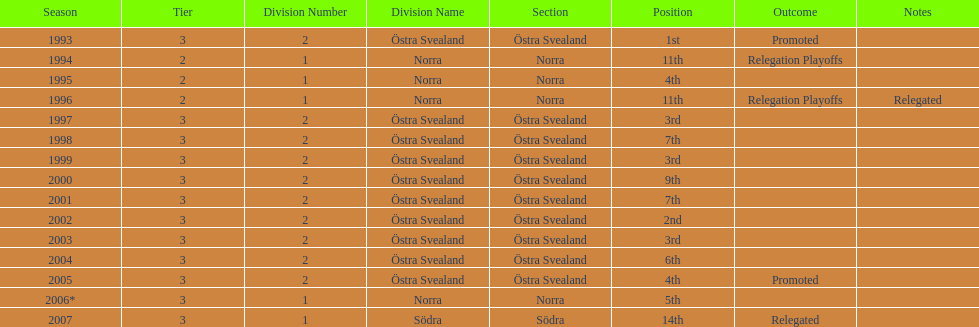What are the number of times norra was listed as the section? 4. Parse the table in full. {'header': ['Season', 'Tier', 'Division Number', 'Division Name', 'Section', 'Position', 'Outcome', 'Notes'], 'rows': [['1993', '3', '2', 'Östra Svealand', 'Östra Svealand', '1st', 'Promoted', ''], ['1994', '2', '1', 'Norra', 'Norra', '11th', 'Relegation Playoffs', ''], ['1995', '2', '1', 'Norra', 'Norra', '4th', '', ''], ['1996', '2', '1', 'Norra', 'Norra', '11th', 'Relegation Playoffs', 'Relegated'], ['1997', '3', '2', 'Östra Svealand', 'Östra Svealand', '3rd', '', ''], ['1998', '3', '2', 'Östra Svealand', 'Östra Svealand', '7th', '', ''], ['1999', '3', '2', 'Östra Svealand', 'Östra Svealand', '3rd', '', ''], ['2000', '3', '2', 'Östra Svealand', 'Östra Svealand', '9th', '', ''], ['2001', '3', '2', 'Östra Svealand', 'Östra Svealand', '7th', '', ''], ['2002', '3', '2', 'Östra Svealand', 'Östra Svealand', '2nd', '', ''], ['2003', '3', '2', 'Östra Svealand', 'Östra Svealand', '3rd', '', ''], ['2004', '3', '2', 'Östra Svealand', 'Östra Svealand', '6th', '', ''], ['2005', '3', '2', 'Östra Svealand', 'Östra Svealand', '4th', 'Promoted', ''], ['2006*', '3', '1', 'Norra', 'Norra', '5th', '', ''], ['2007', '3', '1', 'Södra', 'Södra', '14th', 'Relegated', '']]} 